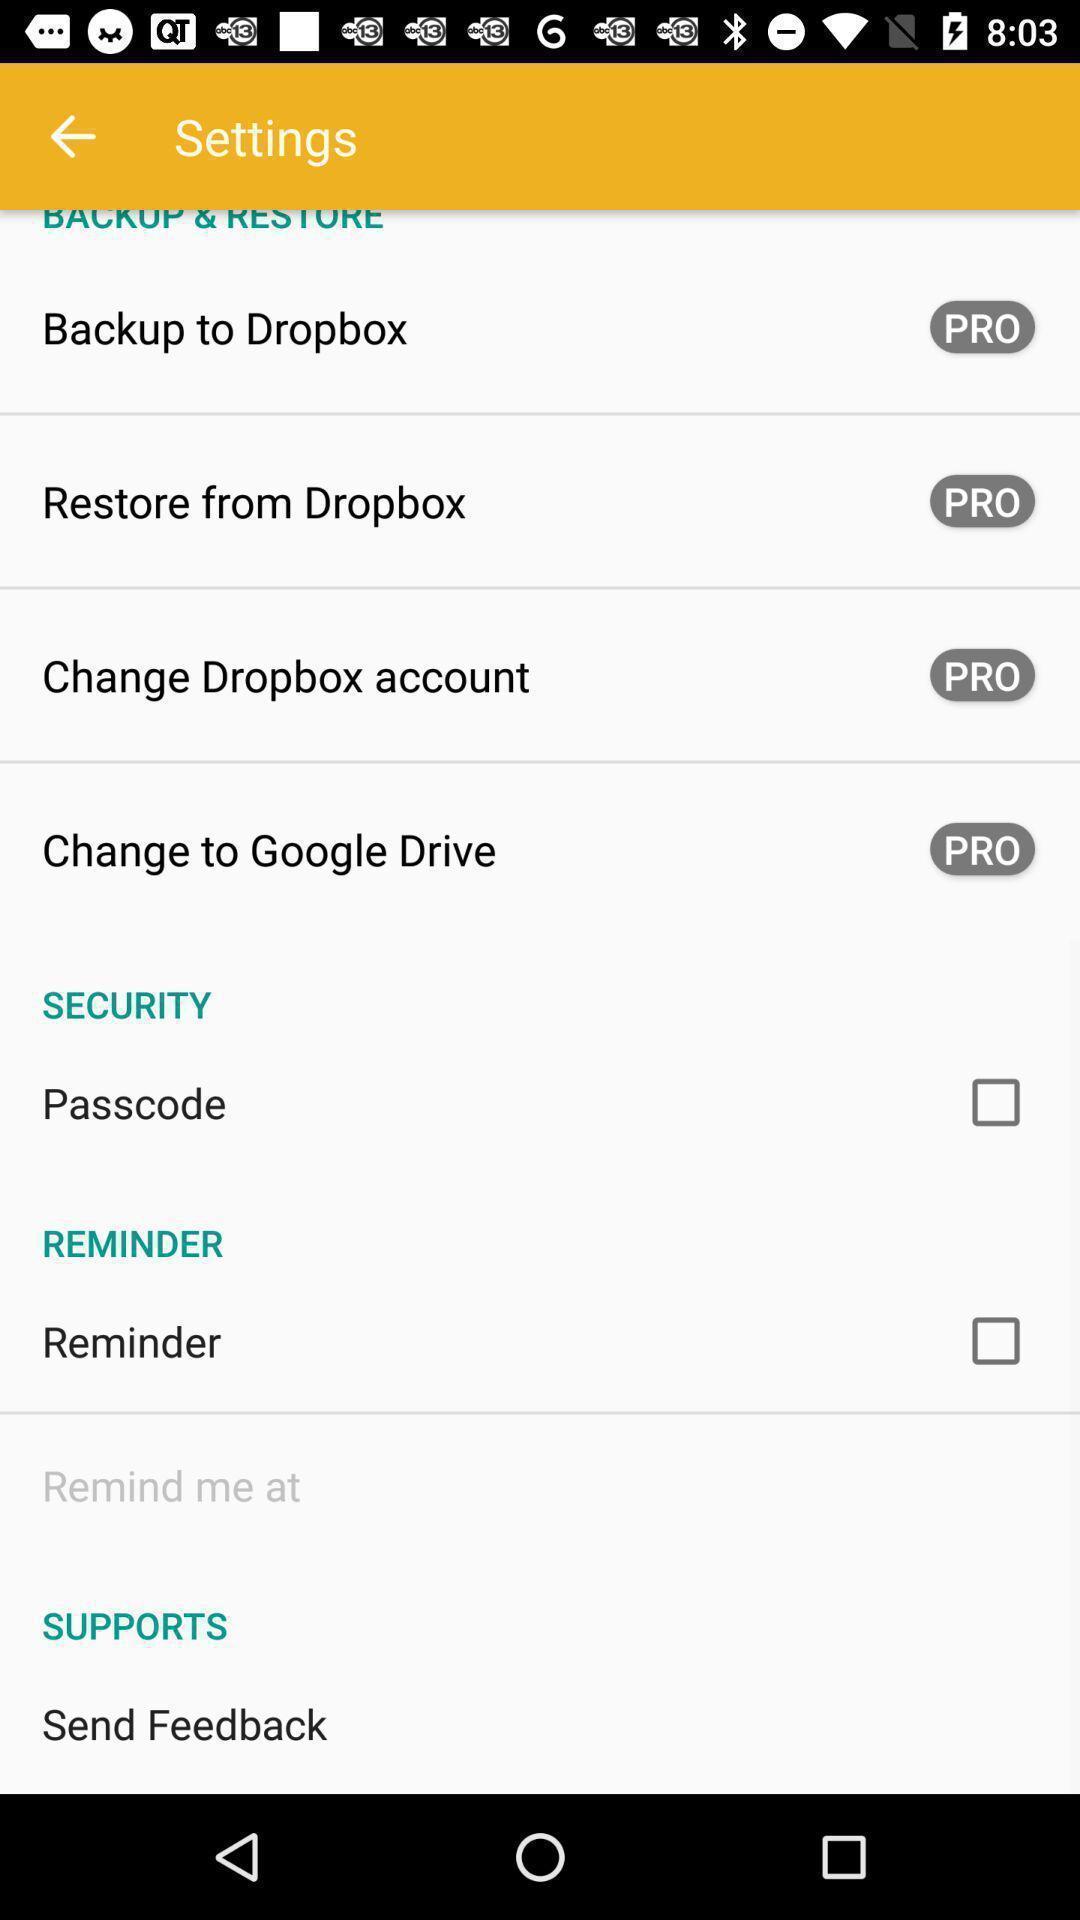Please provide a description for this image. Screen showing settings page. 